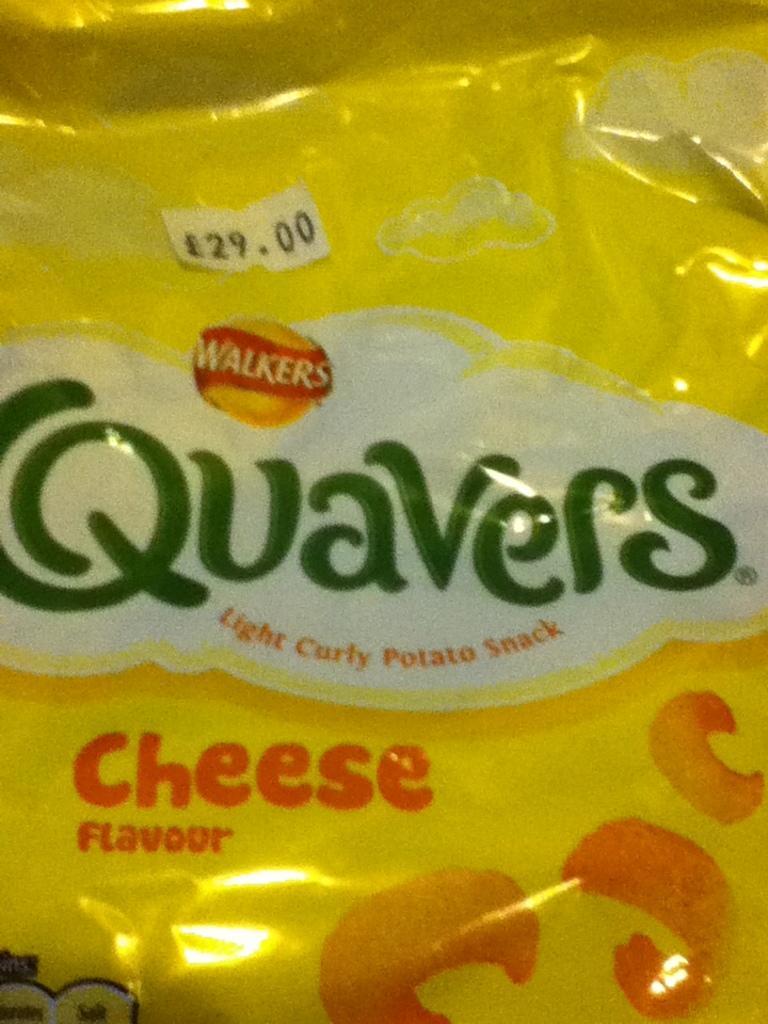How would you summarize this image in a sentence or two? In this image, we can see a packet contains some text on it. 